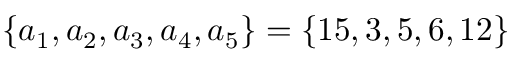<formula> <loc_0><loc_0><loc_500><loc_500>\{ a _ { 1 } , a _ { 2 } , a _ { 3 } , a _ { 4 } , a _ { 5 } \} = \{ 1 5 , 3 , 5 , 6 , 1 2 \}</formula> 